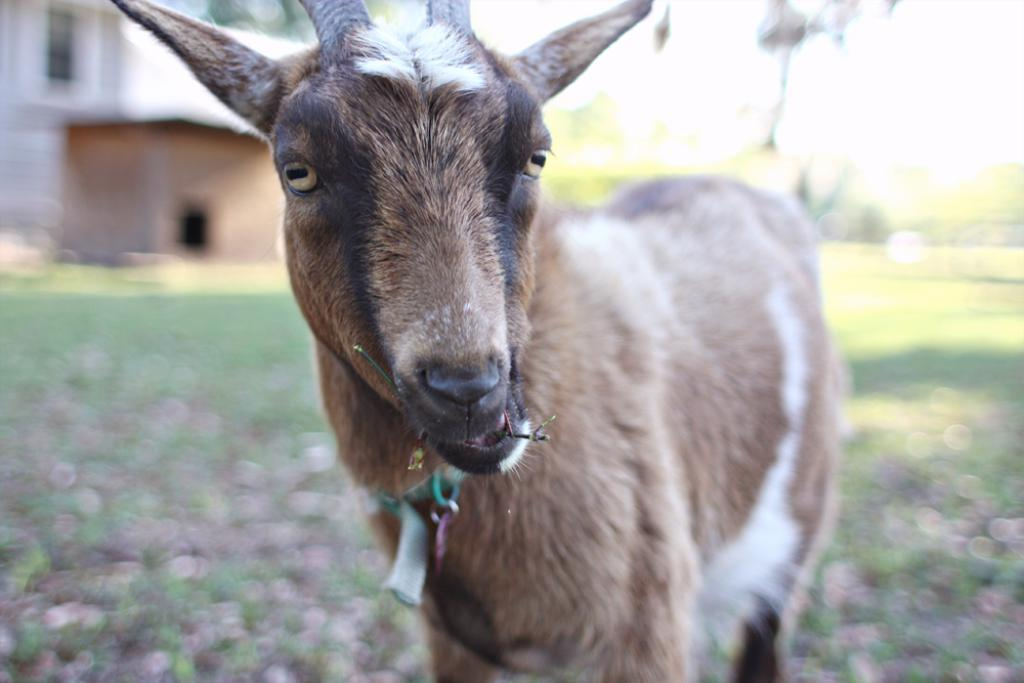What type of animal is in the image? The animal in the image has brown, black, and white coloring, but the specific type cannot be determined from the provided facts. What can be seen in the background of the image? The background of the image is blurry, but buildings, trees, and the sky are visible. What type of things can be cooked in the oven in the image? There is no oven present in the image, so it is not possible to answer that question. 